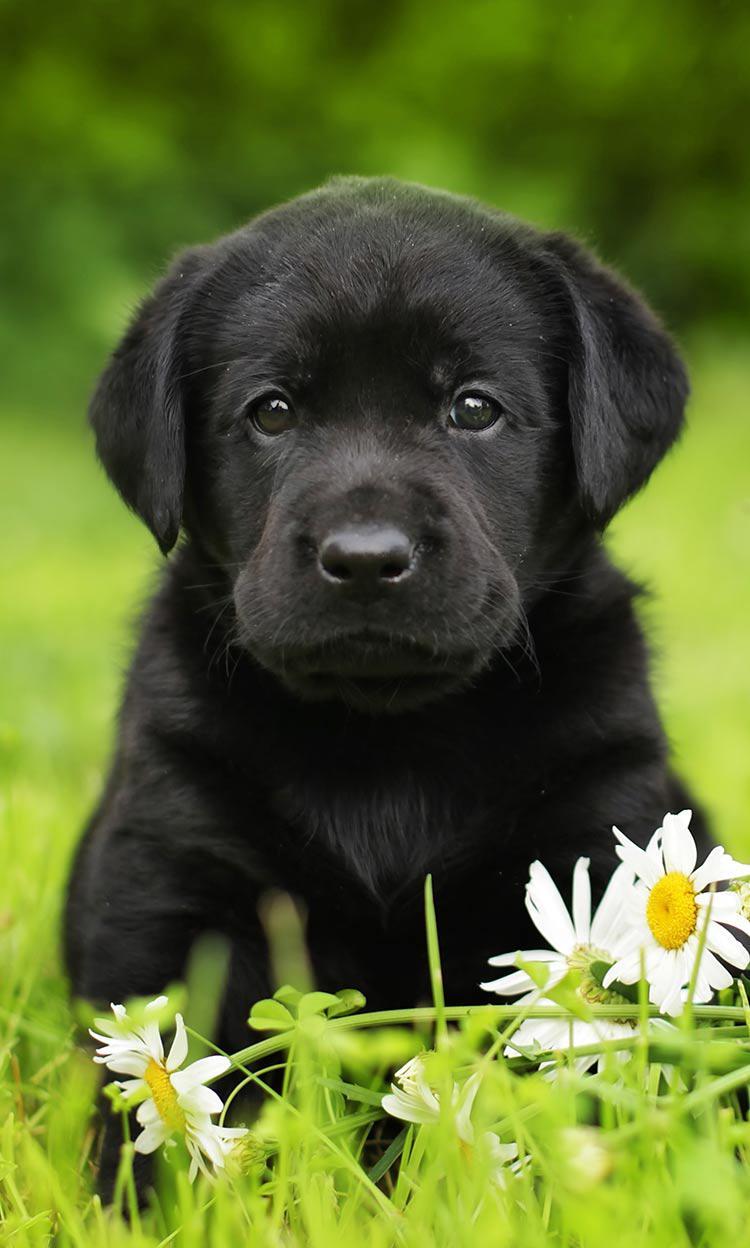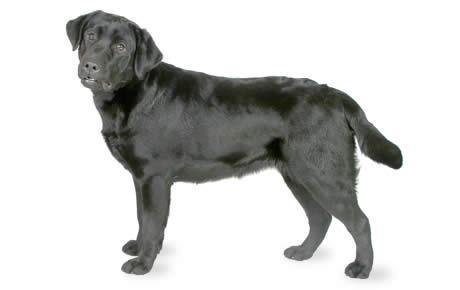The first image is the image on the left, the second image is the image on the right. Considering the images on both sides, is "A dog is standing and facing left." valid? Answer yes or no. Yes. 